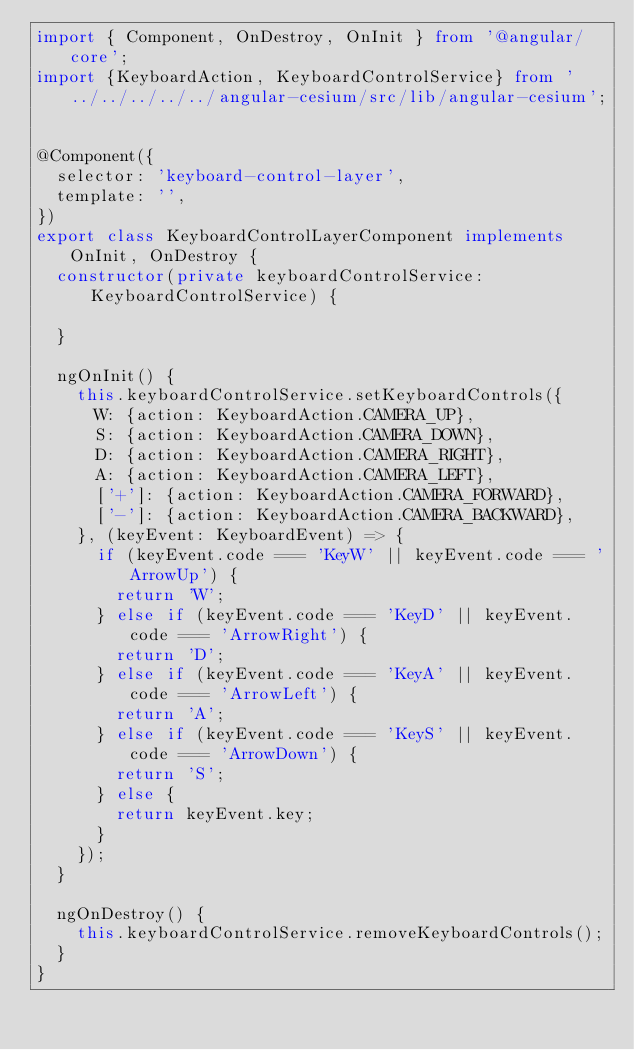Convert code to text. <code><loc_0><loc_0><loc_500><loc_500><_TypeScript_>import { Component, OnDestroy, OnInit } from '@angular/core';
import {KeyboardAction, KeyboardControlService} from '../../../../../angular-cesium/src/lib/angular-cesium';


@Component({
  selector: 'keyboard-control-layer',
  template: '',
})
export class KeyboardControlLayerComponent implements OnInit, OnDestroy {
  constructor(private keyboardControlService: KeyboardControlService) {

  }

  ngOnInit() {
    this.keyboardControlService.setKeyboardControls({
      W: {action: KeyboardAction.CAMERA_UP},
      S: {action: KeyboardAction.CAMERA_DOWN},
      D: {action: KeyboardAction.CAMERA_RIGHT},
      A: {action: KeyboardAction.CAMERA_LEFT},
      ['+']: {action: KeyboardAction.CAMERA_FORWARD},
      ['-']: {action: KeyboardAction.CAMERA_BACKWARD},
    }, (keyEvent: KeyboardEvent) => {
      if (keyEvent.code === 'KeyW' || keyEvent.code === 'ArrowUp') {
        return 'W';
      } else if (keyEvent.code === 'KeyD' || keyEvent.code === 'ArrowRight') {
        return 'D';
      } else if (keyEvent.code === 'KeyA' || keyEvent.code === 'ArrowLeft') {
        return 'A';
      } else if (keyEvent.code === 'KeyS' || keyEvent.code === 'ArrowDown') {
        return 'S';
      } else {
        return keyEvent.key;
      }
    });
  }

  ngOnDestroy() {
    this.keyboardControlService.removeKeyboardControls();
  }
}
</code> 